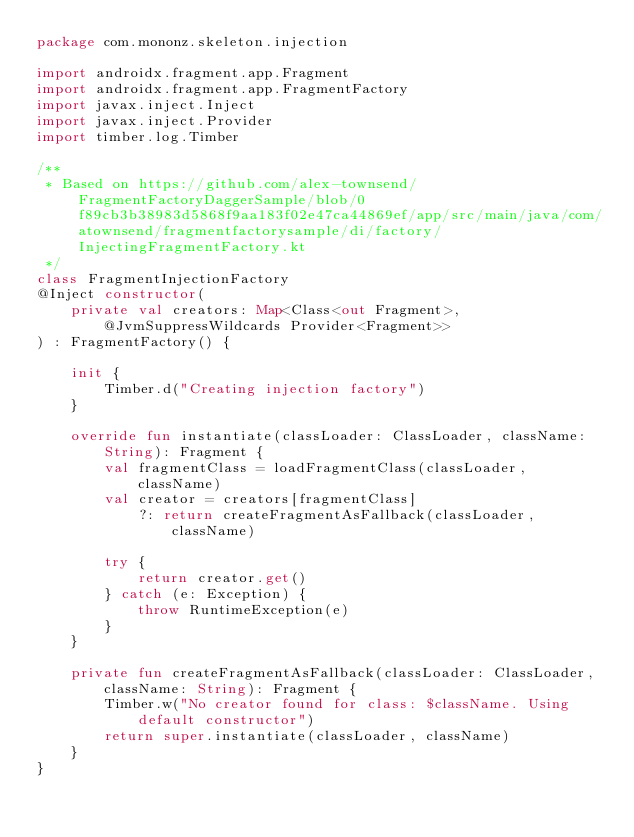<code> <loc_0><loc_0><loc_500><loc_500><_Kotlin_>package com.mononz.skeleton.injection

import androidx.fragment.app.Fragment
import androidx.fragment.app.FragmentFactory
import javax.inject.Inject
import javax.inject.Provider
import timber.log.Timber

/**
 * Based on https://github.com/alex-townsend/FragmentFactoryDaggerSample/blob/0f89cb3b38983d5868f9aa183f02e47ca44869ef/app/src/main/java/com/atownsend/fragmentfactorysample/di/factory/InjectingFragmentFactory.kt
 */
class FragmentInjectionFactory
@Inject constructor(
    private val creators: Map<Class<out Fragment>, @JvmSuppressWildcards Provider<Fragment>>
) : FragmentFactory() {

    init {
        Timber.d("Creating injection factory")
    }

    override fun instantiate(classLoader: ClassLoader, className: String): Fragment {
        val fragmentClass = loadFragmentClass(classLoader, className)
        val creator = creators[fragmentClass]
            ?: return createFragmentAsFallback(classLoader, className)

        try {
            return creator.get()
        } catch (e: Exception) {
            throw RuntimeException(e)
        }
    }

    private fun createFragmentAsFallback(classLoader: ClassLoader, className: String): Fragment {
        Timber.w("No creator found for class: $className. Using default constructor")
        return super.instantiate(classLoader, className)
    }
}
</code> 